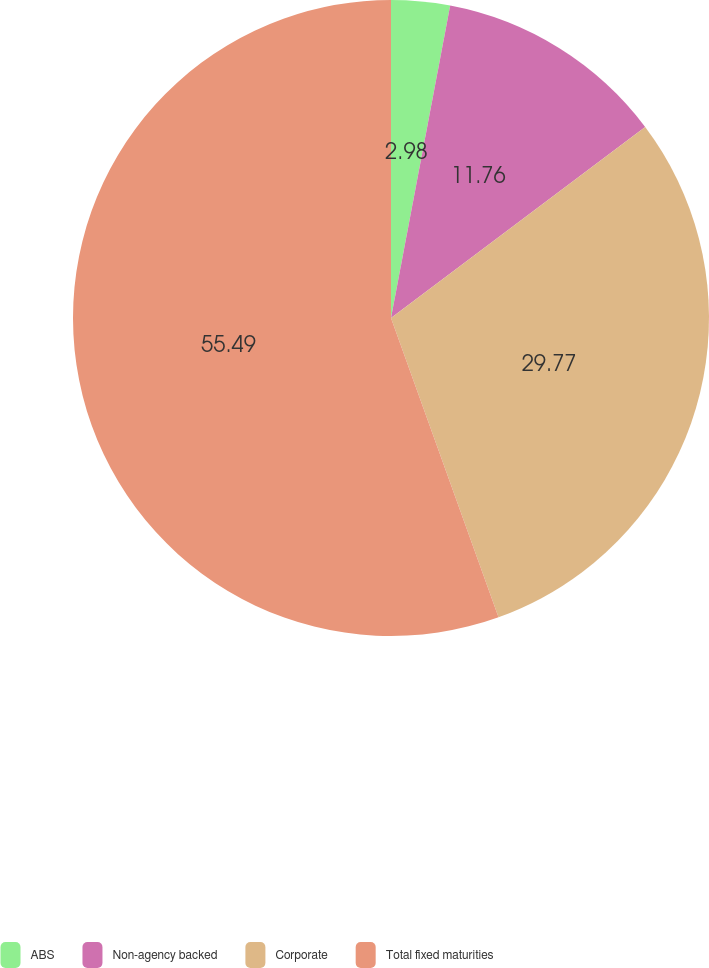<chart> <loc_0><loc_0><loc_500><loc_500><pie_chart><fcel>ABS<fcel>Non-agency backed<fcel>Corporate<fcel>Total fixed maturities<nl><fcel>2.98%<fcel>11.76%<fcel>29.77%<fcel>55.49%<nl></chart> 